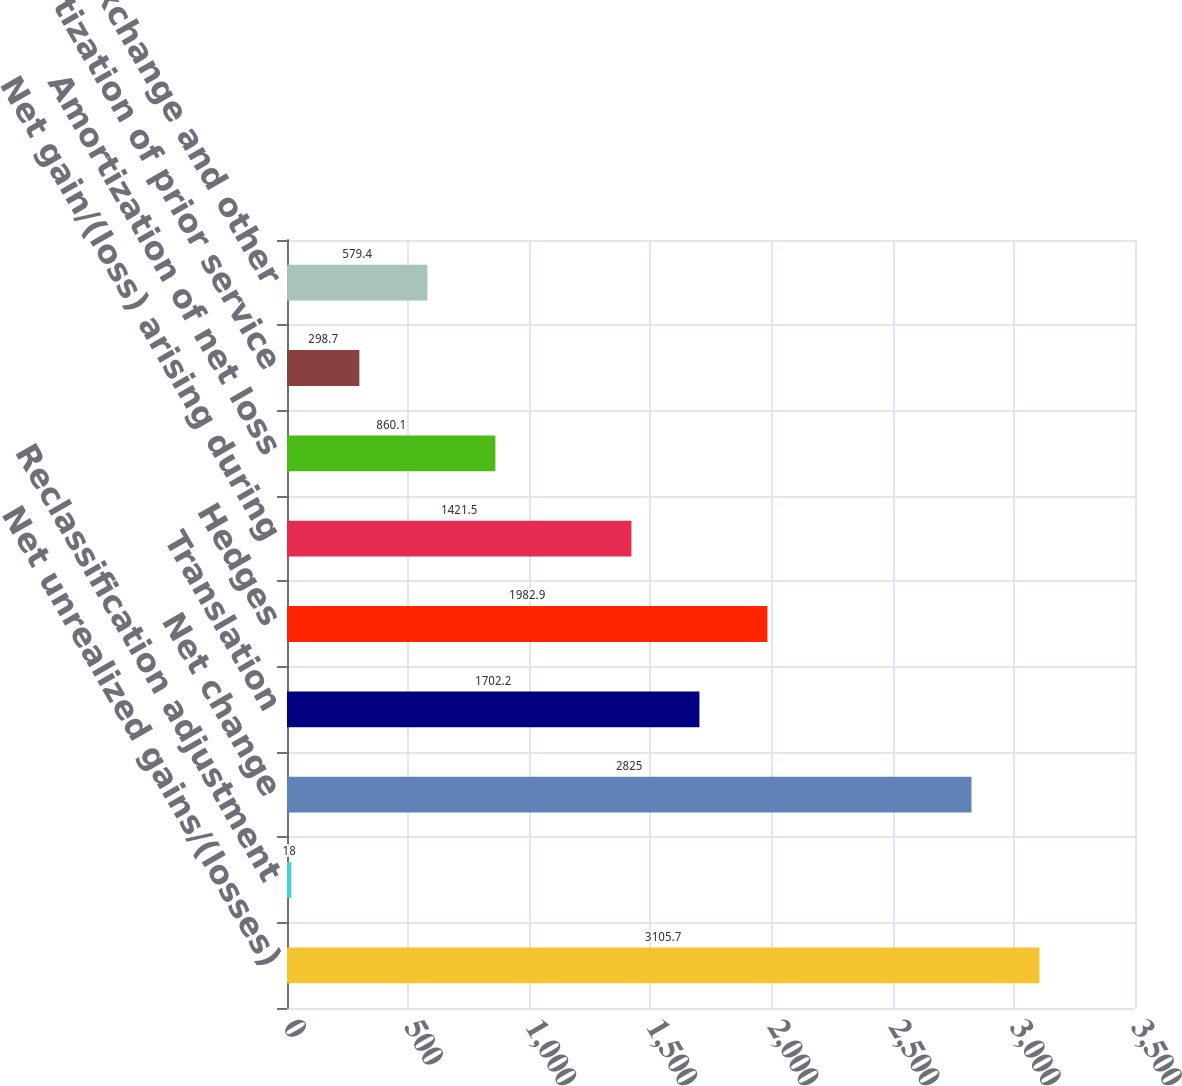<chart> <loc_0><loc_0><loc_500><loc_500><bar_chart><fcel>Net unrealized gains/(losses)<fcel>Reclassification adjustment<fcel>Net change<fcel>Translation<fcel>Hedges<fcel>Net gain/(loss) arising during<fcel>Amortization of net loss<fcel>Amortization of prior service<fcel>Foreign exchange and other<nl><fcel>3105.7<fcel>18<fcel>2825<fcel>1702.2<fcel>1982.9<fcel>1421.5<fcel>860.1<fcel>298.7<fcel>579.4<nl></chart> 